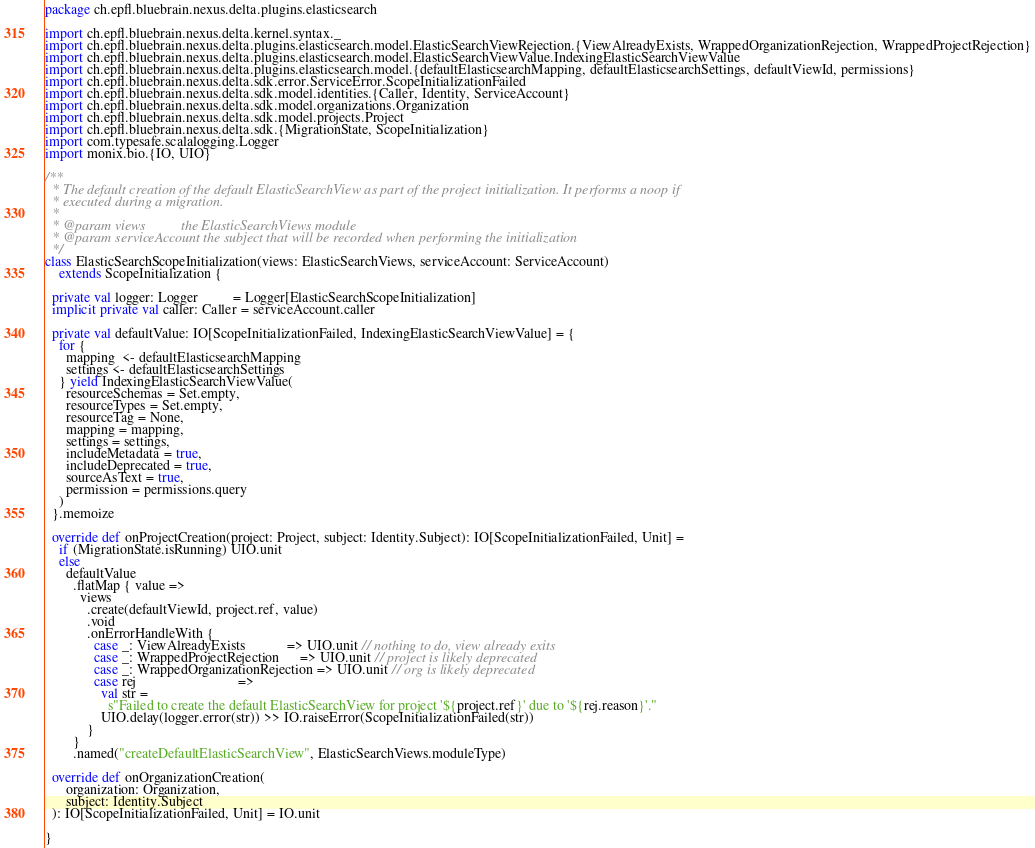Convert code to text. <code><loc_0><loc_0><loc_500><loc_500><_Scala_>package ch.epfl.bluebrain.nexus.delta.plugins.elasticsearch

import ch.epfl.bluebrain.nexus.delta.kernel.syntax._
import ch.epfl.bluebrain.nexus.delta.plugins.elasticsearch.model.ElasticSearchViewRejection.{ViewAlreadyExists, WrappedOrganizationRejection, WrappedProjectRejection}
import ch.epfl.bluebrain.nexus.delta.plugins.elasticsearch.model.ElasticSearchViewValue.IndexingElasticSearchViewValue
import ch.epfl.bluebrain.nexus.delta.plugins.elasticsearch.model.{defaultElasticsearchMapping, defaultElasticsearchSettings, defaultViewId, permissions}
import ch.epfl.bluebrain.nexus.delta.sdk.error.ServiceError.ScopeInitializationFailed
import ch.epfl.bluebrain.nexus.delta.sdk.model.identities.{Caller, Identity, ServiceAccount}
import ch.epfl.bluebrain.nexus.delta.sdk.model.organizations.Organization
import ch.epfl.bluebrain.nexus.delta.sdk.model.projects.Project
import ch.epfl.bluebrain.nexus.delta.sdk.{MigrationState, ScopeInitialization}
import com.typesafe.scalalogging.Logger
import monix.bio.{IO, UIO}

/**
  * The default creation of the default ElasticSearchView as part of the project initialization. It performs a noop if
  * executed during a migration.
  *
  * @param views          the ElasticSearchViews module
  * @param serviceAccount the subject that will be recorded when performing the initialization
  */
class ElasticSearchScopeInitialization(views: ElasticSearchViews, serviceAccount: ServiceAccount)
    extends ScopeInitialization {

  private val logger: Logger          = Logger[ElasticSearchScopeInitialization]
  implicit private val caller: Caller = serviceAccount.caller

  private val defaultValue: IO[ScopeInitializationFailed, IndexingElasticSearchViewValue] = {
    for {
      mapping  <- defaultElasticsearchMapping
      settings <- defaultElasticsearchSettings
    } yield IndexingElasticSearchViewValue(
      resourceSchemas = Set.empty,
      resourceTypes = Set.empty,
      resourceTag = None,
      mapping = mapping,
      settings = settings,
      includeMetadata = true,
      includeDeprecated = true,
      sourceAsText = true,
      permission = permissions.query
    )
  }.memoize

  override def onProjectCreation(project: Project, subject: Identity.Subject): IO[ScopeInitializationFailed, Unit] =
    if (MigrationState.isRunning) UIO.unit
    else
      defaultValue
        .flatMap { value =>
          views
            .create(defaultViewId, project.ref, value)
            .void
            .onErrorHandleWith {
              case _: ViewAlreadyExists            => UIO.unit // nothing to do, view already exits
              case _: WrappedProjectRejection      => UIO.unit // project is likely deprecated
              case _: WrappedOrganizationRejection => UIO.unit // org is likely deprecated
              case rej                             =>
                val str =
                  s"Failed to create the default ElasticSearchView for project '${project.ref}' due to '${rej.reason}'."
                UIO.delay(logger.error(str)) >> IO.raiseError(ScopeInitializationFailed(str))
            }
        }
        .named("createDefaultElasticSearchView", ElasticSearchViews.moduleType)

  override def onOrganizationCreation(
      organization: Organization,
      subject: Identity.Subject
  ): IO[ScopeInitializationFailed, Unit] = IO.unit

}
</code> 